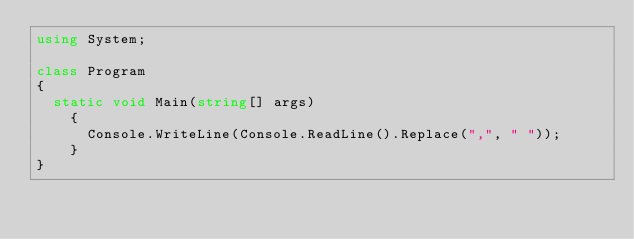Convert code to text. <code><loc_0><loc_0><loc_500><loc_500><_C#_>using System;

class Program
{
	static void Main(string[] args)
    {
    	Console.WriteLine(Console.ReadLine().Replace(",", " "));
    }
}</code> 